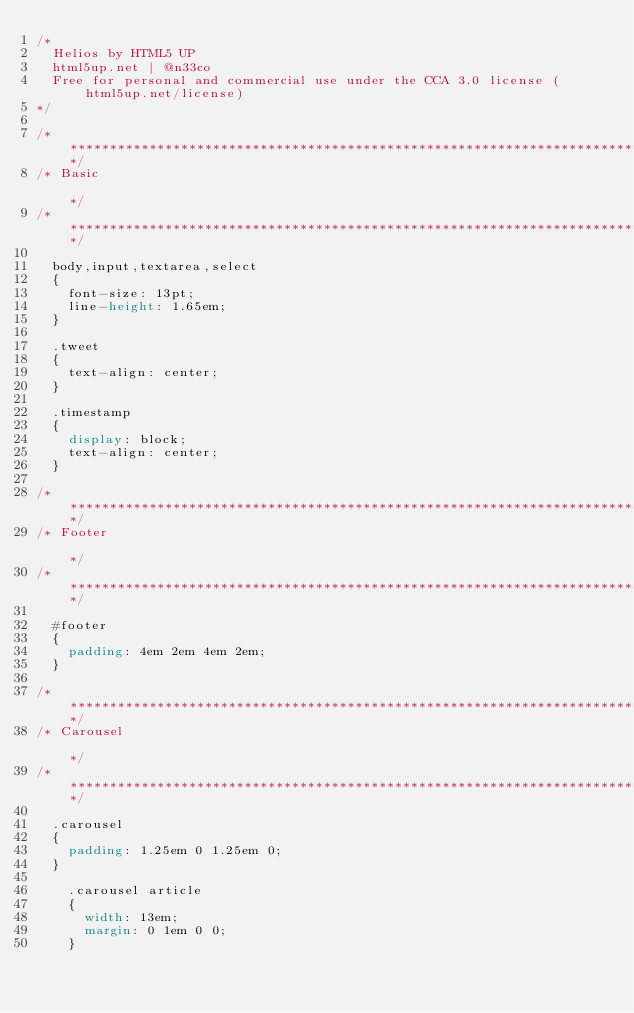Convert code to text. <code><loc_0><loc_0><loc_500><loc_500><_CSS_>/*
	Helios by HTML5 UP
	html5up.net | @n33co
	Free for personal and commercial use under the CCA 3.0 license (html5up.net/license)
*/

/*********************************************************************************/
/* Basic                                                                         */
/*********************************************************************************/

	body,input,textarea,select
	{
		font-size: 13pt;
		line-height: 1.65em;
	}

	.tweet
	{
		text-align: center;
	}

	.timestamp
	{
		display: block;
		text-align: center;
	}

/*********************************************************************************/
/* Footer                                                                        */
/*********************************************************************************/

	#footer
	{
		padding: 4em 2em 4em 2em;
	}
	
/*********************************************************************************/
/* Carousel                                                                      */
/*********************************************************************************/

	.carousel
	{
		padding: 1.25em 0 1.25em 0;
	}

		.carousel article
		{
			width: 13em;
			margin: 0 1em 0 0;
		}</code> 